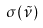Convert formula to latex. <formula><loc_0><loc_0><loc_500><loc_500>\sigma ( \tilde { \nu } )</formula> 